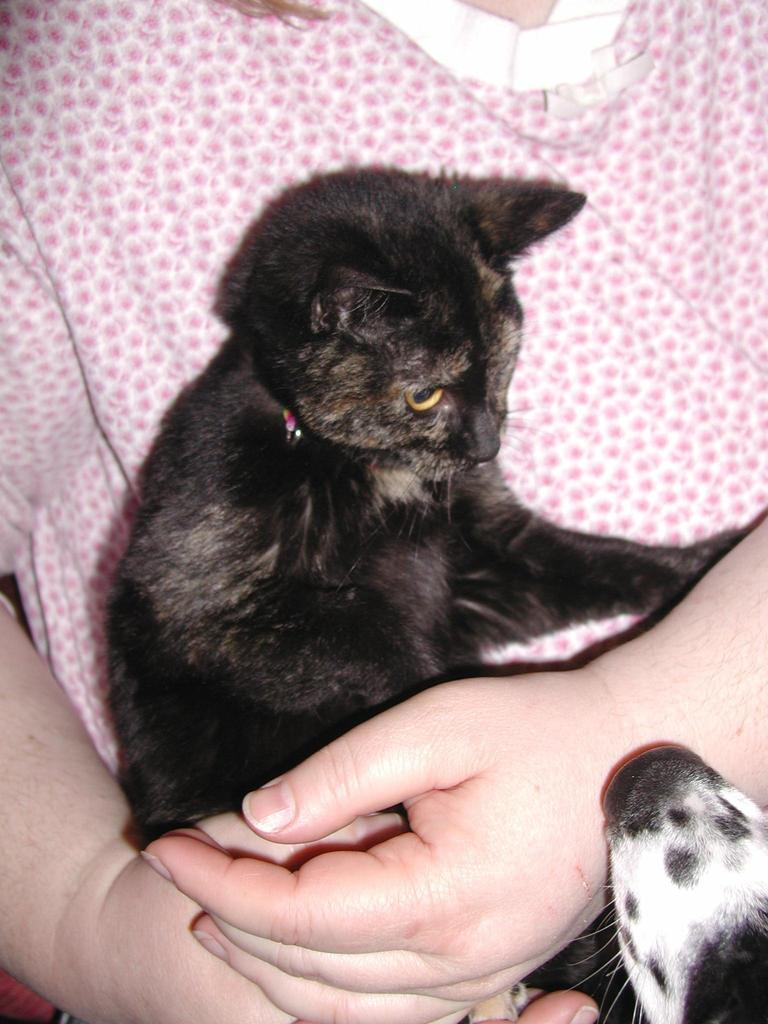Who is the main subject in the image? There is a woman in the image. What is the woman wearing? The woman is wearing a pink dress. What is the woman holding in her hands? The woman is holding a black cat in her hands. Are there any animals in the image besides the cat? Yes, there is a dog in the image. Where is the dog located in the image? The dog's face is visible in the right bottom of the picture. What type of pail is the woman using to collect water in the image? There is no pail present in the image; the woman is holding a black cat in her hands. 